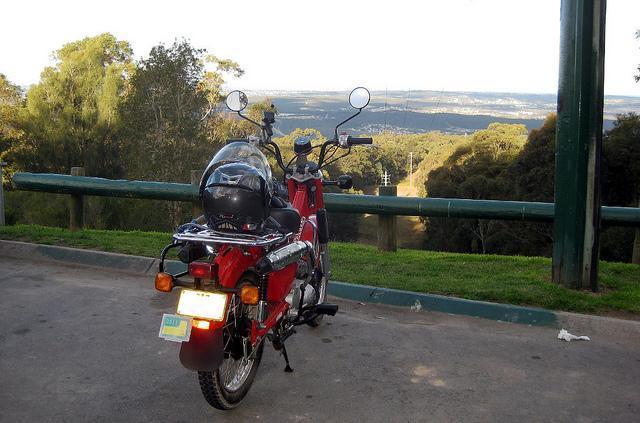How many tires are on the bike?
Give a very brief answer. 2. 